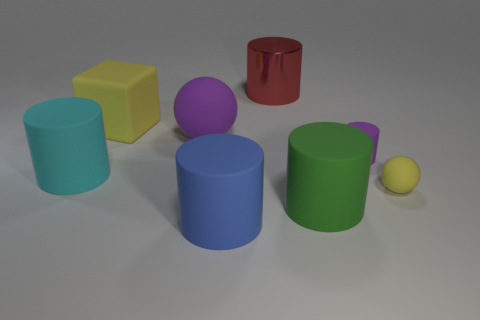Is there anything else that has the same material as the large red cylinder?
Offer a very short reply. No. There is a sphere that is left of the red shiny cylinder; does it have the same color as the rubber cylinder that is behind the cyan thing?
Provide a short and direct response. Yes. What number of yellow things are either metal spheres or shiny things?
Give a very brief answer. 0. Is the number of rubber objects that are right of the cyan matte object less than the number of large yellow rubber blocks that are on the right side of the large purple matte thing?
Provide a succinct answer. No. Are there any balls of the same size as the metal cylinder?
Your answer should be very brief. Yes. Do the red metallic thing behind the blue matte cylinder and the big purple thing have the same size?
Your response must be concise. Yes. Are there more large rubber objects than cubes?
Your answer should be compact. Yes. Are there any cyan objects that have the same shape as the big blue matte thing?
Your answer should be very brief. Yes. There is a yellow matte object that is behind the cyan rubber object; what shape is it?
Give a very brief answer. Cube. There is a yellow rubber thing left of the red shiny thing behind the tiny yellow ball; what number of big yellow matte objects are behind it?
Offer a terse response. 0. 